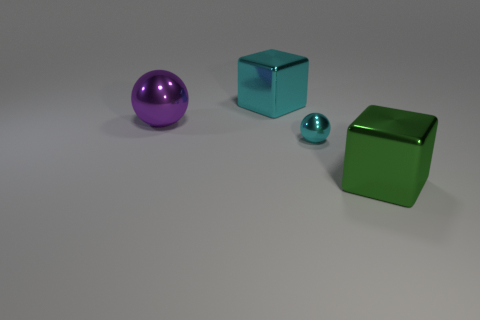Is there any other thing that is the same size as the cyan sphere?
Provide a short and direct response. No. There is a metallic ball that is on the right side of the cyan object that is on the left side of the small sphere; are there any tiny objects that are in front of it?
Ensure brevity in your answer.  No. There is a ball on the right side of the cyan object behind the purple metal object; what is its material?
Make the answer very short. Metal. There is a thing that is in front of the cyan shiny cube and to the left of the small cyan object; what material is it?
Offer a terse response. Metal. Is there a big cyan thing that has the same shape as the green object?
Keep it short and to the point. Yes. There is a large metallic cube in front of the cyan metallic block; are there any metal balls that are in front of it?
Keep it short and to the point. No. How many cyan balls are made of the same material as the green cube?
Give a very brief answer. 1. Are any shiny cubes visible?
Your answer should be compact. Yes. What number of other small things are the same color as the tiny metal thing?
Offer a very short reply. 0. Does the big cyan block have the same material as the ball that is behind the cyan metallic ball?
Your answer should be compact. Yes. 